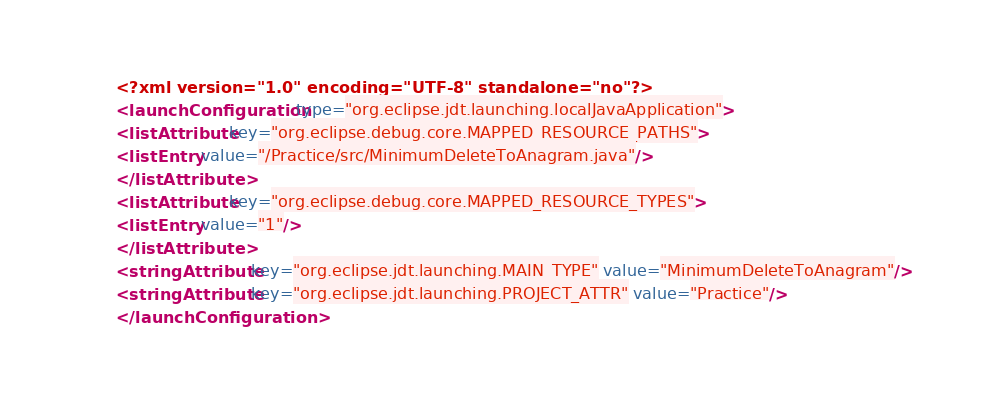Convert code to text. <code><loc_0><loc_0><loc_500><loc_500><_XML_><?xml version="1.0" encoding="UTF-8" standalone="no"?>
<launchConfiguration type="org.eclipse.jdt.launching.localJavaApplication">
<listAttribute key="org.eclipse.debug.core.MAPPED_RESOURCE_PATHS">
<listEntry value="/Practice/src/MinimumDeleteToAnagram.java"/>
</listAttribute>
<listAttribute key="org.eclipse.debug.core.MAPPED_RESOURCE_TYPES">
<listEntry value="1"/>
</listAttribute>
<stringAttribute key="org.eclipse.jdt.launching.MAIN_TYPE" value="MinimumDeleteToAnagram"/>
<stringAttribute key="org.eclipse.jdt.launching.PROJECT_ATTR" value="Practice"/>
</launchConfiguration>
</code> 